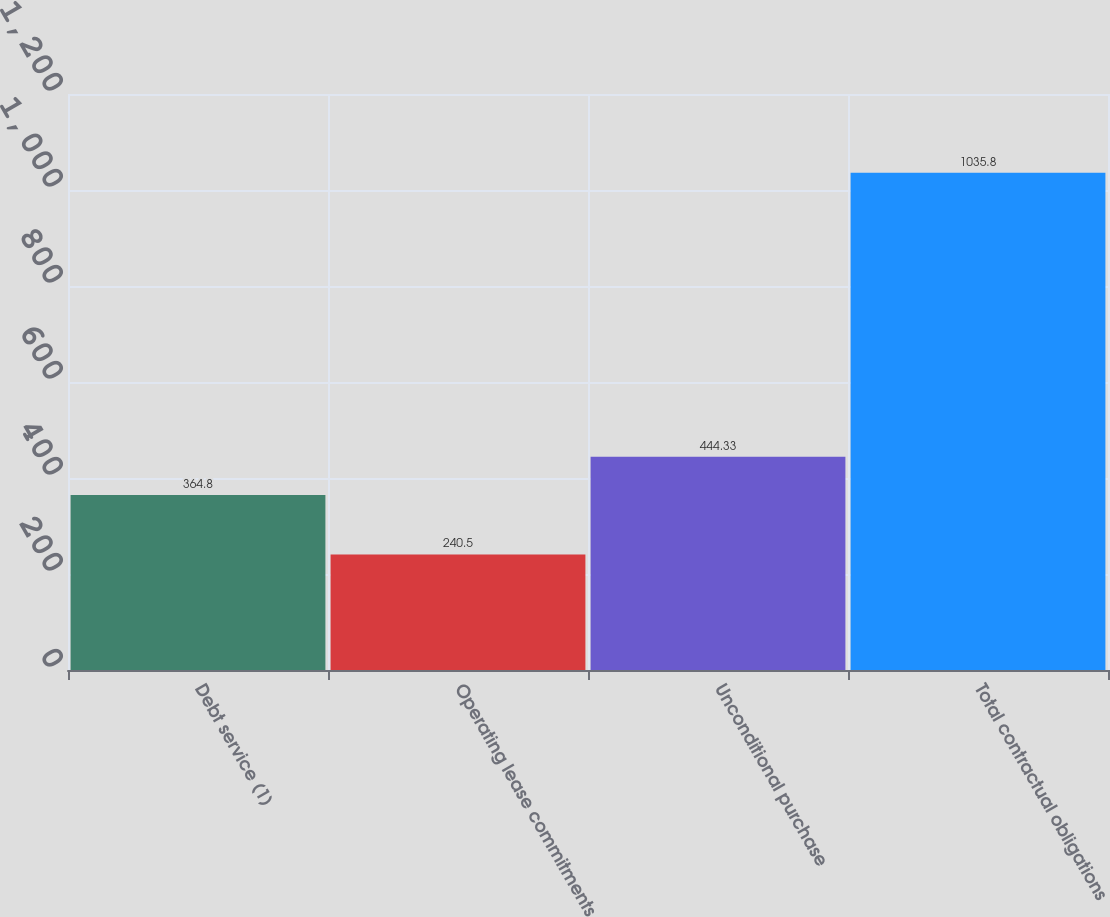Convert chart to OTSL. <chart><loc_0><loc_0><loc_500><loc_500><bar_chart><fcel>Debt service (1)<fcel>Operating lease commitments<fcel>Unconditional purchase<fcel>Total contractual obligations<nl><fcel>364.8<fcel>240.5<fcel>444.33<fcel>1035.8<nl></chart> 